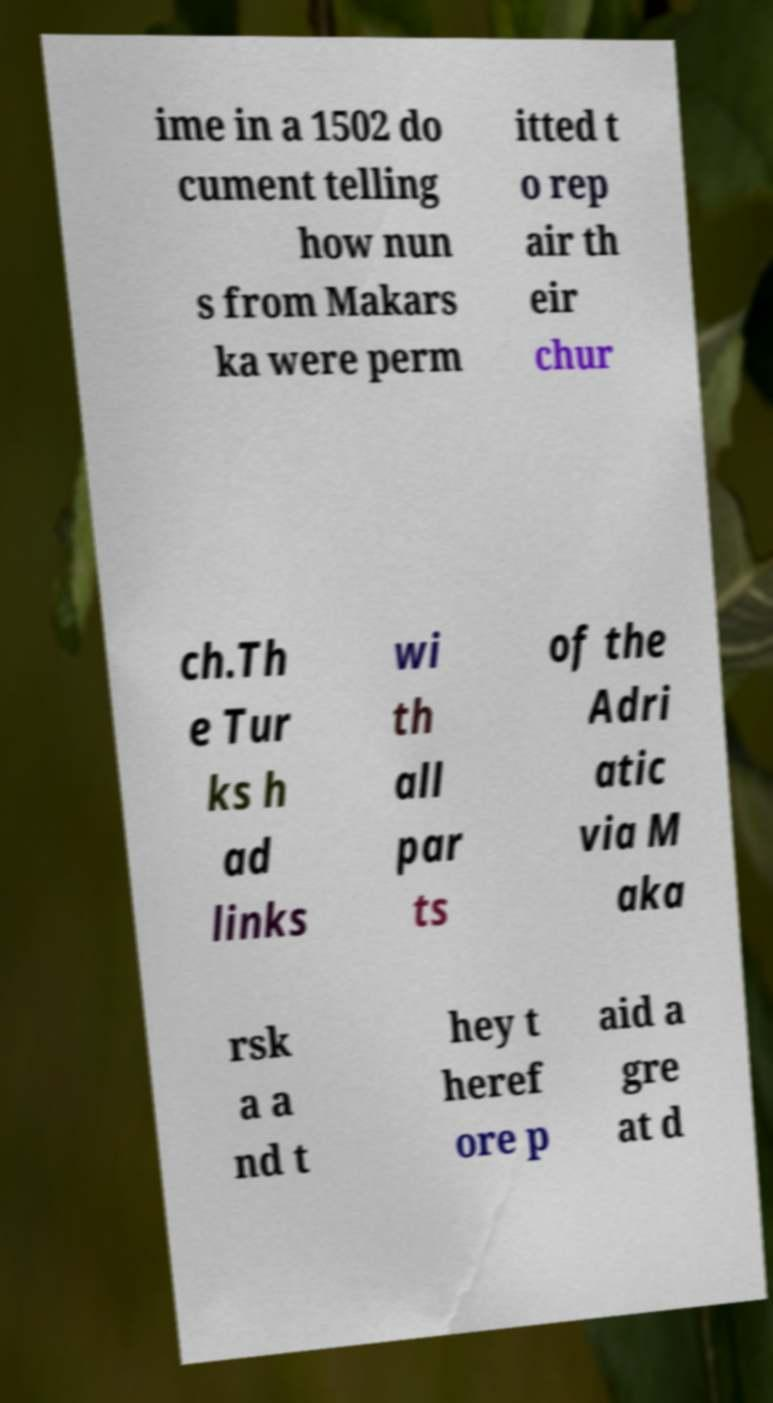Can you read and provide the text displayed in the image?This photo seems to have some interesting text. Can you extract and type it out for me? ime in a 1502 do cument telling how nun s from Makars ka were perm itted t o rep air th eir chur ch.Th e Tur ks h ad links wi th all par ts of the Adri atic via M aka rsk a a nd t hey t heref ore p aid a gre at d 